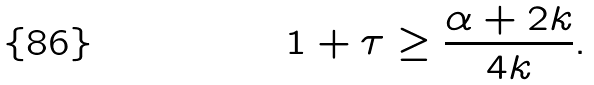Convert formula to latex. <formula><loc_0><loc_0><loc_500><loc_500>1 + \tau \geq \frac { \alpha + 2 k } { 4 k } .</formula> 